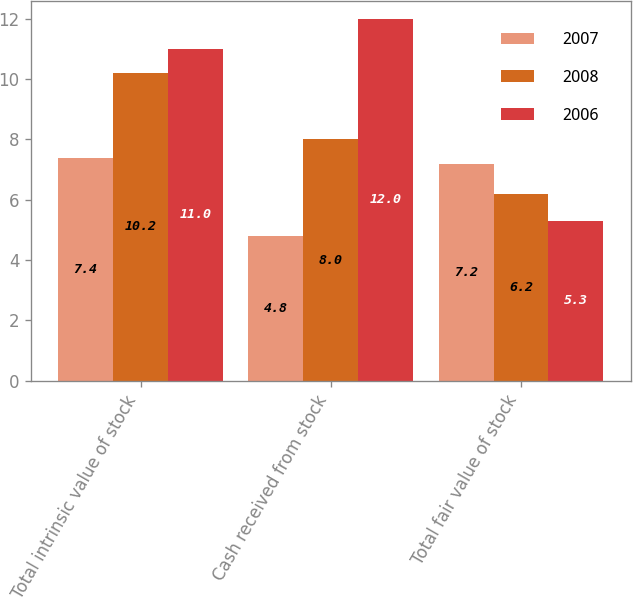<chart> <loc_0><loc_0><loc_500><loc_500><stacked_bar_chart><ecel><fcel>Total intrinsic value of stock<fcel>Cash received from stock<fcel>Total fair value of stock<nl><fcel>2007<fcel>7.4<fcel>4.8<fcel>7.2<nl><fcel>2008<fcel>10.2<fcel>8<fcel>6.2<nl><fcel>2006<fcel>11<fcel>12<fcel>5.3<nl></chart> 